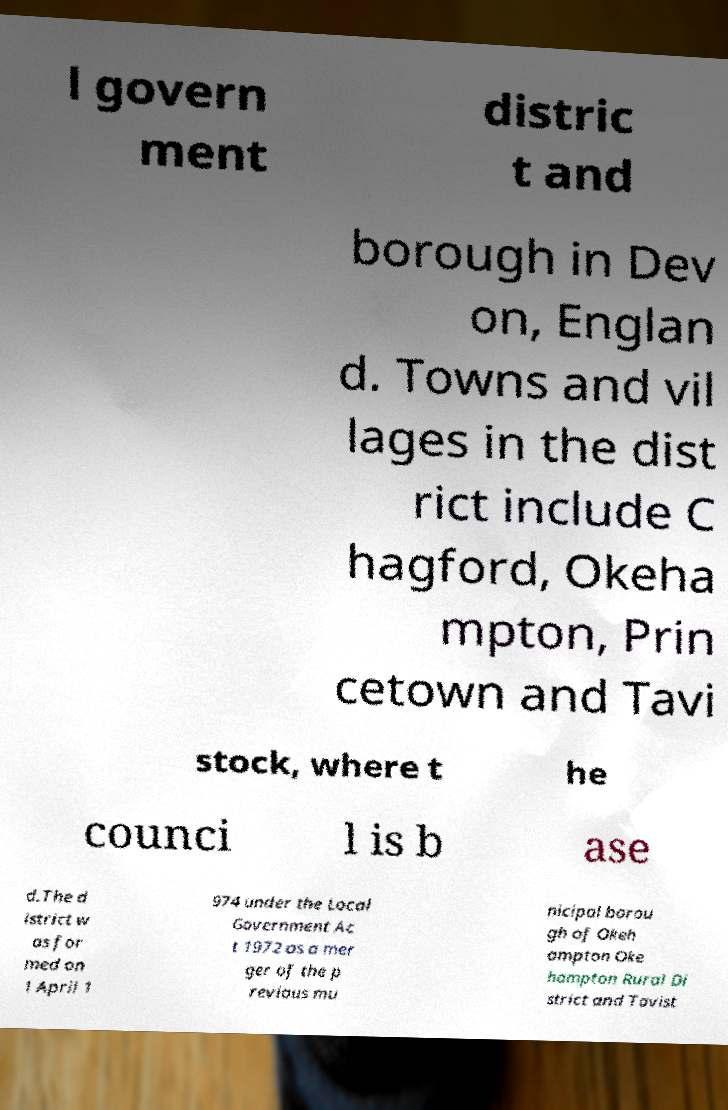Please read and relay the text visible in this image. What does it say? l govern ment distric t and borough in Dev on, Englan d. Towns and vil lages in the dist rict include C hagford, Okeha mpton, Prin cetown and Tavi stock, where t he counci l is b ase d.The d istrict w as for med on 1 April 1 974 under the Local Government Ac t 1972 as a mer ger of the p revious mu nicipal borou gh of Okeh ampton Oke hampton Rural Di strict and Tavist 